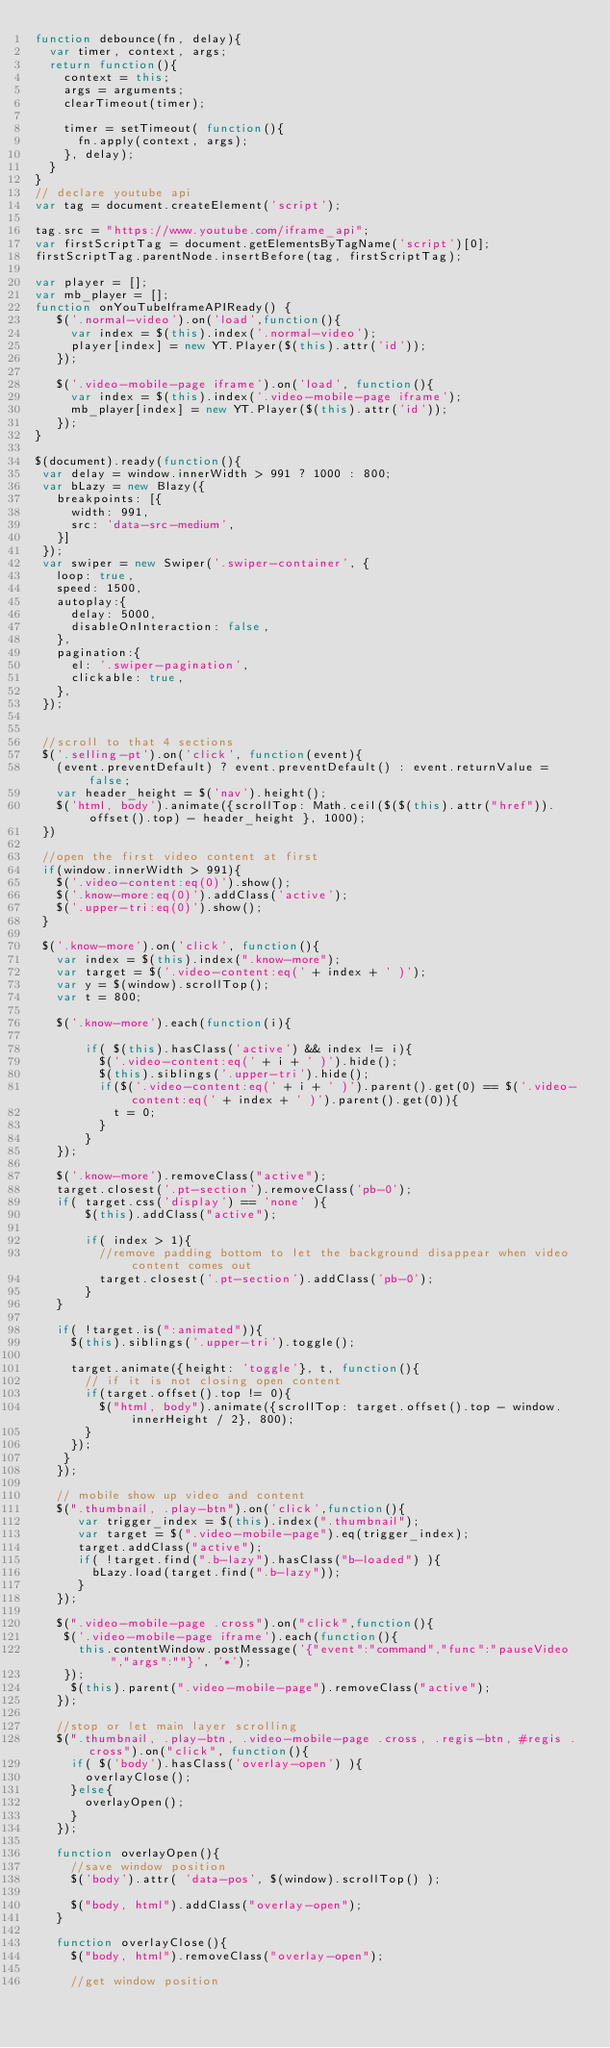<code> <loc_0><loc_0><loc_500><loc_500><_JavaScript_>function debounce(fn, delay){
  var timer, context, args;
  return function(){
    context = this;
    args = arguments;
    clearTimeout(timer);

    timer = setTimeout( function(){
      fn.apply(context, args);
    }, delay);
  }
}
// declare youtube api
var tag = document.createElement('script');

tag.src = "https://www.youtube.com/iframe_api";
var firstScriptTag = document.getElementsByTagName('script')[0];
firstScriptTag.parentNode.insertBefore(tag, firstScriptTag);

var player = [];
var mb_player = [];
function onYouTubeIframeAPIReady() {
   $('.normal-video').on('load',function(){
     var index = $(this).index('.normal-video');
     player[index] = new YT.Player($(this).attr('id'));
   });

   $('.video-mobile-page iframe').on('load', function(){
     var index = $(this).index('.video-mobile-page iframe');
     mb_player[index] = new YT.Player($(this).attr('id'));
   });
}

$(document).ready(function(){
 var delay = window.innerWidth > 991 ? 1000 : 800;
 var bLazy = new Blazy({
   breakpoints: [{
     width: 991,
     src: 'data-src-medium',
   }]
 });
 var swiper = new Swiper('.swiper-container', {
   loop: true,
   speed: 1500,
   autoplay:{
     delay: 5000,
     disableOnInteraction: false,
   },
   pagination:{
     el: '.swiper-pagination',
     clickable: true,
   },
 });


 //scroll to that 4 sections
 $('.selling-pt').on('click', function(event){
   (event.preventDefault) ? event.preventDefault() : event.returnValue = false;
   var header_height = $('nav').height();
   $('html, body').animate({scrollTop: Math.ceil($($(this).attr("href")).offset().top) - header_height }, 1000);
 })

 //open the first video content at first
 if(window.innerWidth > 991){
   $('.video-content:eq(0)').show();
   $('.know-more:eq(0)').addClass('active');
   $('.upper-tri:eq(0)').show();
 }

 $('.know-more').on('click', function(){
   var index = $(this).index(".know-more");
   var target = $('.video-content:eq(' + index + ' )');
   var y = $(window).scrollTop();
   var t = 800;

   $('.know-more').each(function(i){

       if( $(this).hasClass('active') && index != i){
         $('.video-content:eq(' + i + ' )').hide();
         $(this).siblings('.upper-tri').hide();
         if($('.video-content:eq(' + i + ' )').parent().get(0) == $('.video-content:eq(' + index + ' )').parent().get(0)){
           t = 0;
         }
       }
   });

   $('.know-more').removeClass("active");
   target.closest('.pt-section').removeClass('pb-0');
   if( target.css('display') == 'none' ){
       $(this).addClass("active");

       if( index > 1){
         //remove padding bottom to let the background disappear when video content comes out
         target.closest('.pt-section').addClass('pb-0');
       }
   }

   if( !target.is(":animated")){
     $(this).siblings('.upper-tri').toggle();

     target.animate({height: 'toggle'}, t, function(){
       // if it is not closing open content
       if(target.offset().top != 0){
         $("html, body").animate({scrollTop: target.offset().top - window.innerHeight / 2}, 800);
       }
     });
    }
   });

   // mobile show up video and content
   $(".thumbnail, .play-btn").on('click',function(){
      var trigger_index = $(this).index(".thumbnail");
      var target = $(".video-mobile-page").eq(trigger_index);
      target.addClass("active");
      if( !target.find(".b-lazy").hasClass("b-loaded") ){
        bLazy.load(target.find(".b-lazy"));
      }
   });

   $(".video-mobile-page .cross").on("click",function(){
    $('.video-mobile-page iframe').each(function(){
      this.contentWindow.postMessage('{"event":"command","func":"pauseVideo","args":""}', '*');
    });
     $(this).parent(".video-mobile-page").removeClass("active");
   });

   //stop or let main layer scrolling
   $(".thumbnail, .play-btn, .video-mobile-page .cross, .regis-btn, #regis .cross").on("click", function(){
     if( $('body').hasClass('overlay-open') ){
       overlayClose();
     }else{
       overlayOpen();
     }
   });

   function overlayOpen(){
     //save window position
     $('body').attr( 'data-pos', $(window).scrollTop() );

     $("body, html").addClass("overlay-open");
   }

   function overlayClose(){
     $("body, html").removeClass("overlay-open");

     //get window position</code> 